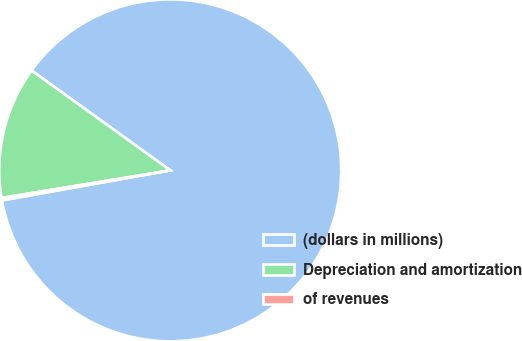<chart> <loc_0><loc_0><loc_500><loc_500><pie_chart><fcel>(dollars in millions)<fcel>Depreciation and amortization<fcel>of revenues<nl><fcel>87.26%<fcel>12.51%<fcel>0.23%<nl></chart> 